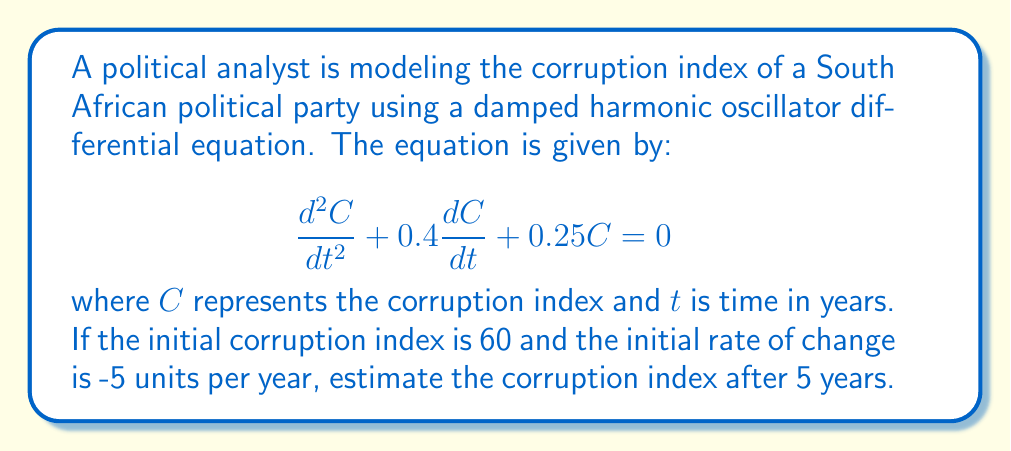What is the answer to this math problem? To solve this problem, we need to follow these steps:

1) The general solution for a damped harmonic oscillator is:

   $$C(t) = e^{-\frac{bt}{2}}(A\cos(\omega t) + B\sin(\omega t))$$

   where $b$ is the damping coefficient, and $\omega$ is the angular frequency.

2) From the given equation, we can identify:
   $b = 0.4$ and $\omega^2 = 0.25 - (\frac{b}{2})^2 = 0.25 - 0.04 = 0.21$

   Therefore, $\omega = \sqrt{0.21} \approx 0.458$

3) The general solution becomes:

   $$C(t) = e^{-0.2t}(A\cos(0.458t) + B\sin(0.458t))$$

4) Using the initial conditions:
   At $t=0$, $C(0) = 60$ and $C'(0) = -5$

5) Applying these conditions:
   $C(0) = A = 60$
   $C'(0) = -0.2A + 0.458B = -5$

6) Solving for B:
   $-0.2(60) + 0.458B = -5$
   $0.458B = 7$
   $B \approx 15.28$

7) The specific solution is:

   $$C(t) = e^{-0.2t}(60\cos(0.458t) + 15.28\sin(0.458t))$$

8) To find C(5), we substitute t=5:

   $$C(5) = e^{-1}(60\cos(2.29) + 15.28\sin(2.29))$$

9) Calculating this value:

   $$C(5) \approx 0.368 * (-33.76 + 13.98) \approx -7.28$$
Answer: The estimated corruption index after 5 years is approximately -7.28 units. 